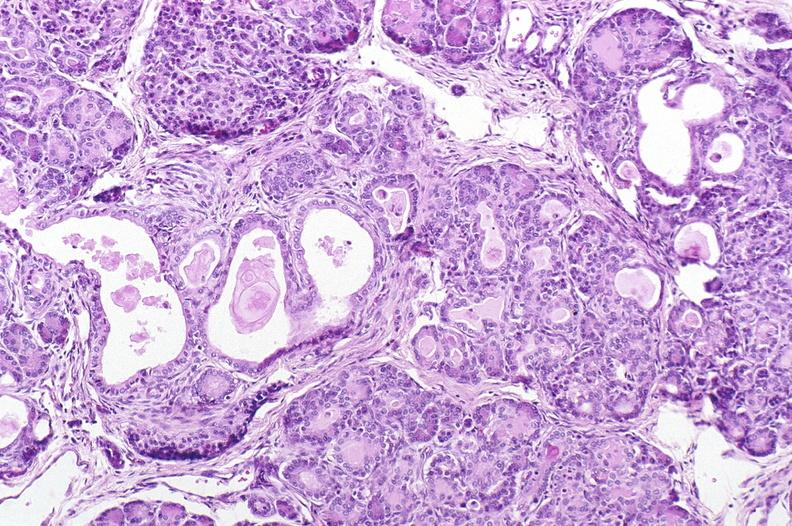what is present?
Answer the question using a single word or phrase. Pancreas 